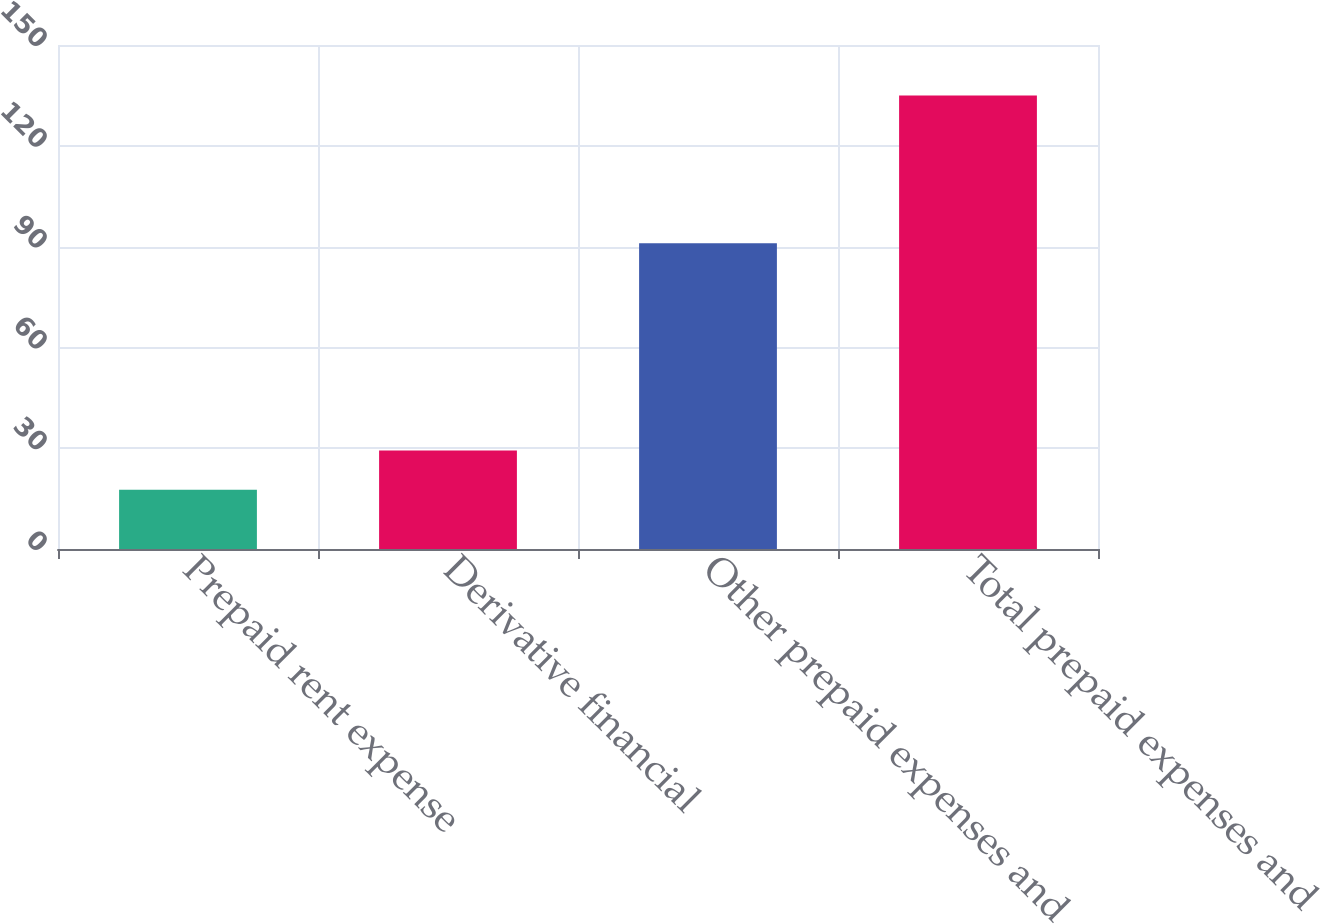Convert chart to OTSL. <chart><loc_0><loc_0><loc_500><loc_500><bar_chart><fcel>Prepaid rent expense<fcel>Derivative financial<fcel>Other prepaid expenses and<fcel>Total prepaid expenses and<nl><fcel>17.6<fcel>29.34<fcel>91<fcel>135<nl></chart> 